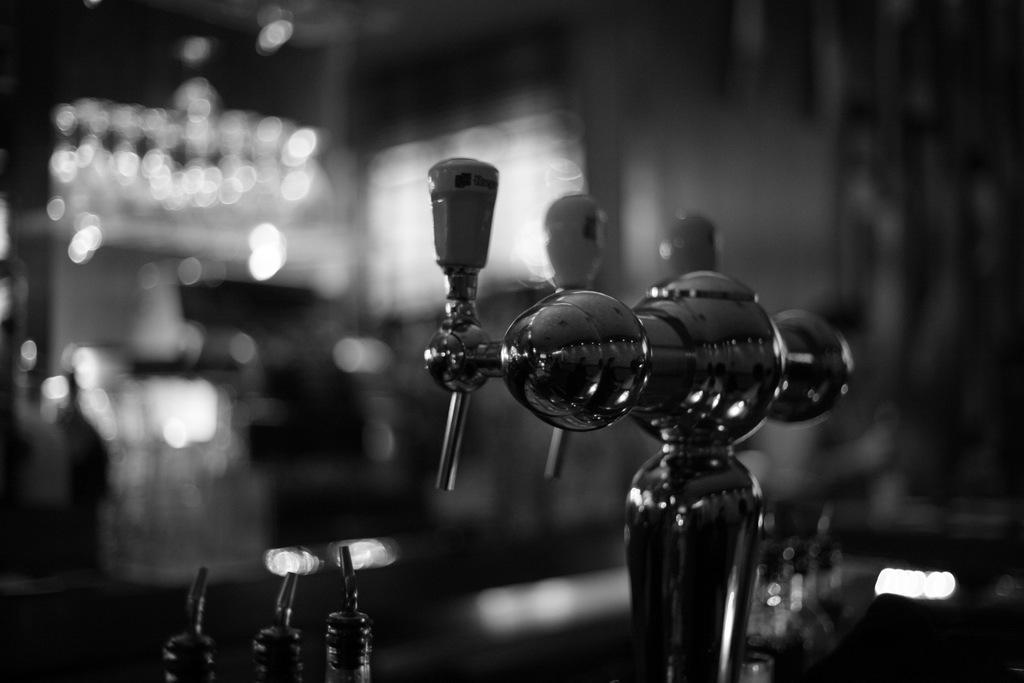What can be seen in the foreground of the image? There are objects in the foreground of the image. Where might these objects be located? The objects may be on the floor. What is visible in the background of the image? There is a wall and windows in the background of the image. What color are the windows? The windows are blue. What type of room might the image have been taken in? The image may have been taken in a hall. How many ladybugs can be seen crawling on the objects in the foreground? There are no ladybugs present in the image. What type of cub is playing with the objects in the foreground? There is no cub present in the image. 